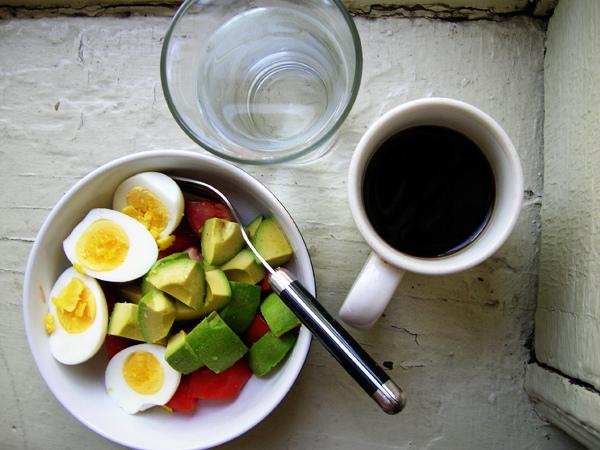How many people are probably going to eat this food?
Be succinct. 1. How many bowls?
Answer briefly. 1. What is the green stuff in the bowl?
Be succinct. Avocado. What is the green fruit?
Be succinct. Avocado. What type of food is in the bowls?
Be succinct. Breakfast. Are these fried eggs?
Give a very brief answer. No. What is in the cups on the plates?
Concise answer only. Water and coffee. Is there a spoon in the cup?
Concise answer only. No. How many egg slices are there?
Give a very brief answer. 4. Is that a leaf pattern in the coffee?
Short answer required. No. 